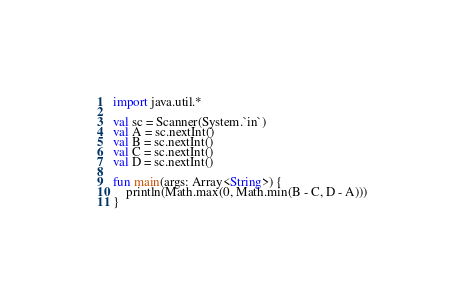<code> <loc_0><loc_0><loc_500><loc_500><_Kotlin_>import java.util.*

val sc = Scanner(System.`in`)
val A = sc.nextInt()
val B = sc.nextInt()
val C = sc.nextInt()
val D = sc.nextInt()

fun main(args: Array<String>) {
    println(Math.max(0, Math.min(B - C, D - A)))
}
</code> 